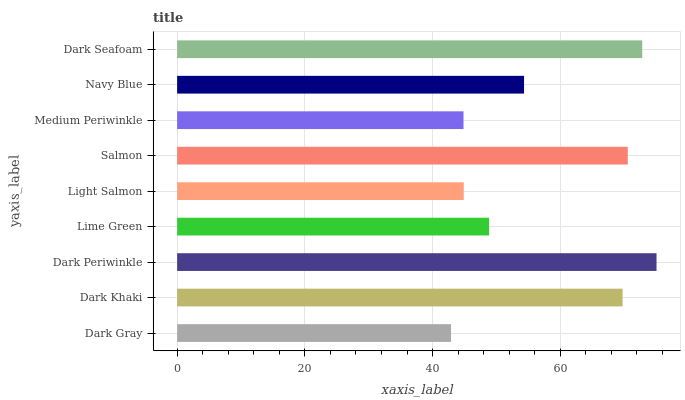Is Dark Gray the minimum?
Answer yes or no. Yes. Is Dark Periwinkle the maximum?
Answer yes or no. Yes. Is Dark Khaki the minimum?
Answer yes or no. No. Is Dark Khaki the maximum?
Answer yes or no. No. Is Dark Khaki greater than Dark Gray?
Answer yes or no. Yes. Is Dark Gray less than Dark Khaki?
Answer yes or no. Yes. Is Dark Gray greater than Dark Khaki?
Answer yes or no. No. Is Dark Khaki less than Dark Gray?
Answer yes or no. No. Is Navy Blue the high median?
Answer yes or no. Yes. Is Navy Blue the low median?
Answer yes or no. Yes. Is Dark Periwinkle the high median?
Answer yes or no. No. Is Medium Periwinkle the low median?
Answer yes or no. No. 